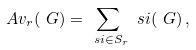Convert formula to latex. <formula><loc_0><loc_0><loc_500><loc_500>\ A v _ { r } ( \ G ) = \sum _ { \ s i \in S _ { r } } \ s i ( \ G ) \, ,</formula> 